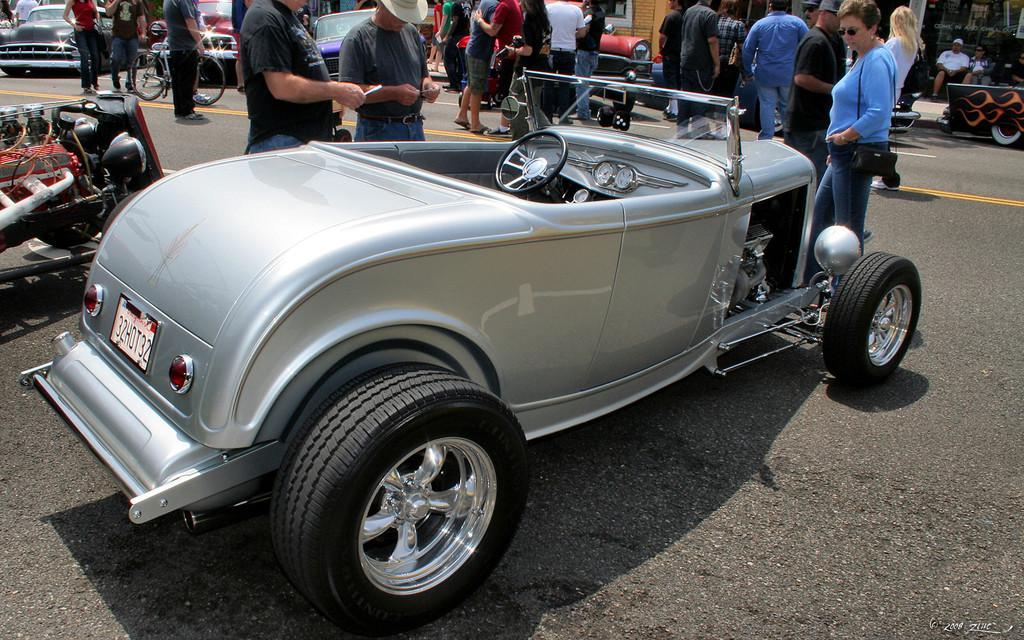What is the main subject of the image? There is a car on the road in the image. What can be seen in the background of the image? There are people standing and other cars visible in the background of the image. Where is the road located in the image? The road is present at the bottom of the image. What type of knowledge can be gained from the road in the image? The image does not convey any specific knowledge or information about the road; it simply shows a car on the road. How many friends are present in the image? There is no mention of friends in the image; it only shows a car on the road and people and other cars in the background. 